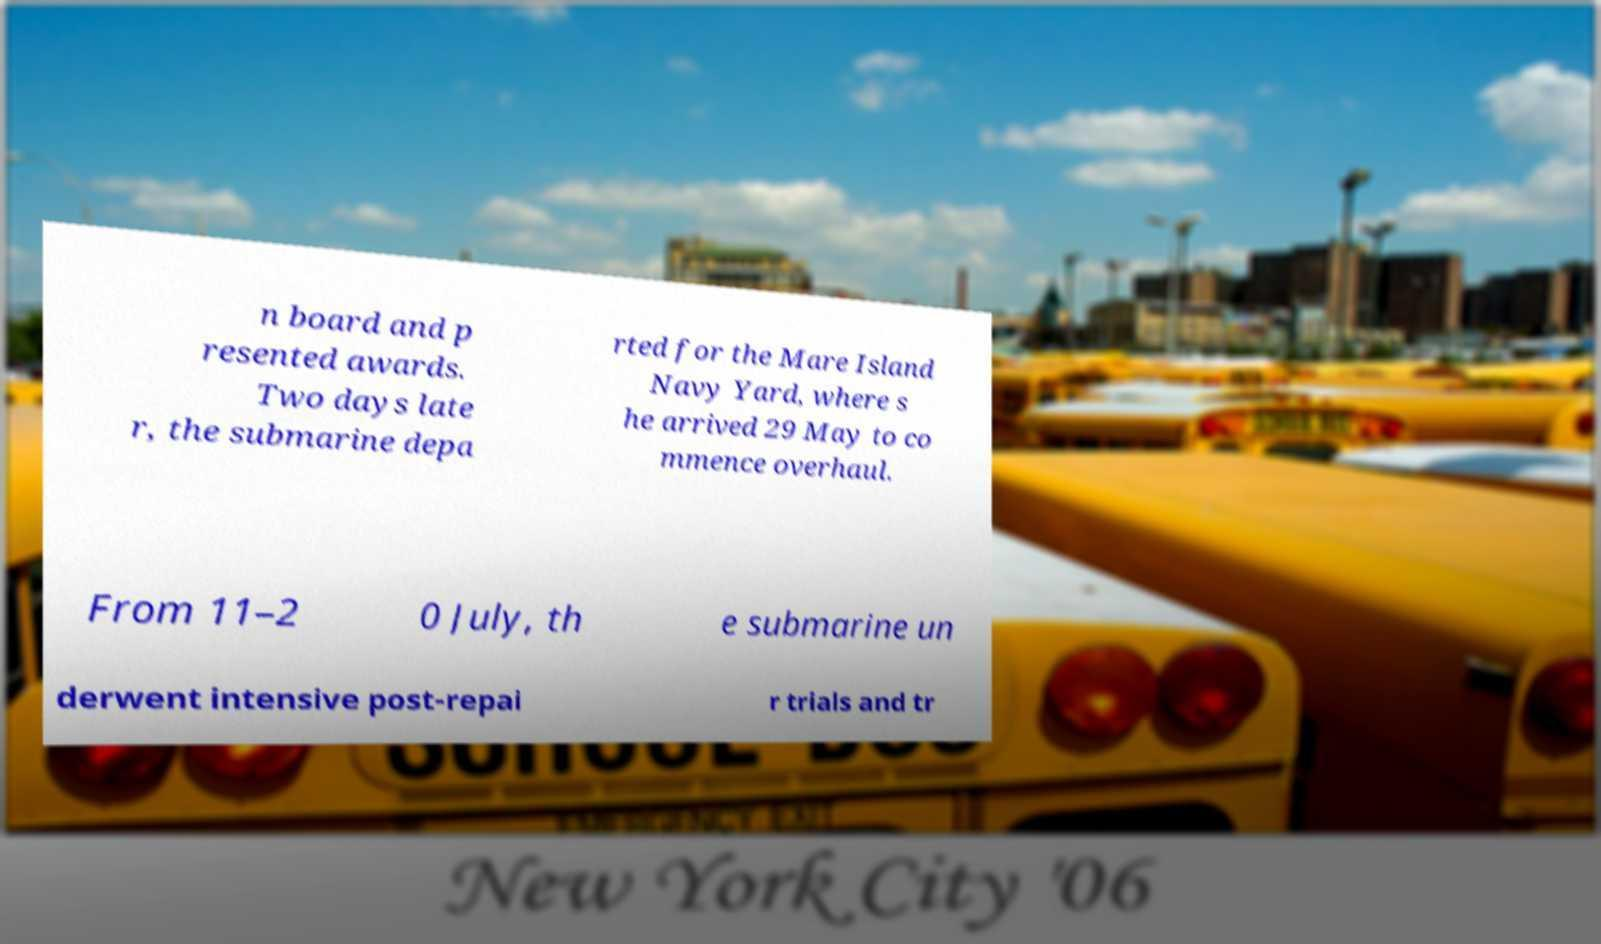Please read and relay the text visible in this image. What does it say? n board and p resented awards. Two days late r, the submarine depa rted for the Mare Island Navy Yard, where s he arrived 29 May to co mmence overhaul. From 11–2 0 July, th e submarine un derwent intensive post-repai r trials and tr 